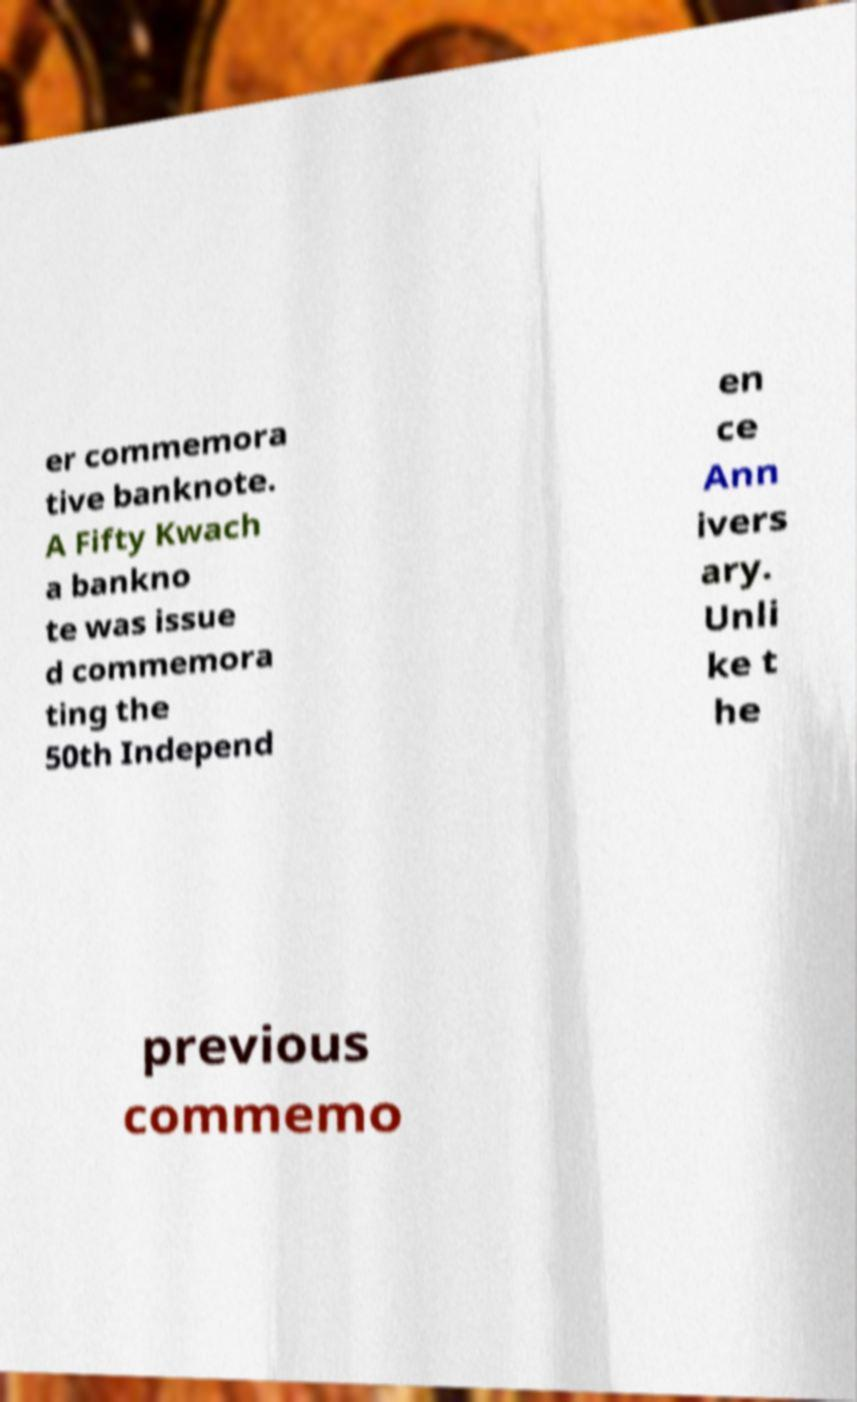Can you read and provide the text displayed in the image?This photo seems to have some interesting text. Can you extract and type it out for me? er commemora tive banknote. A Fifty Kwach a bankno te was issue d commemora ting the 50th Independ en ce Ann ivers ary. Unli ke t he previous commemo 